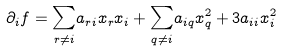<formula> <loc_0><loc_0><loc_500><loc_500>\partial _ { i } f = \underset { r \neq i } { \sum } a _ { r i } x _ { r } x _ { i } + \underset { q \neq i } { \sum } a _ { i q } x _ { q } ^ { 2 } + 3 a _ { i i } x _ { i } ^ { 2 }</formula> 